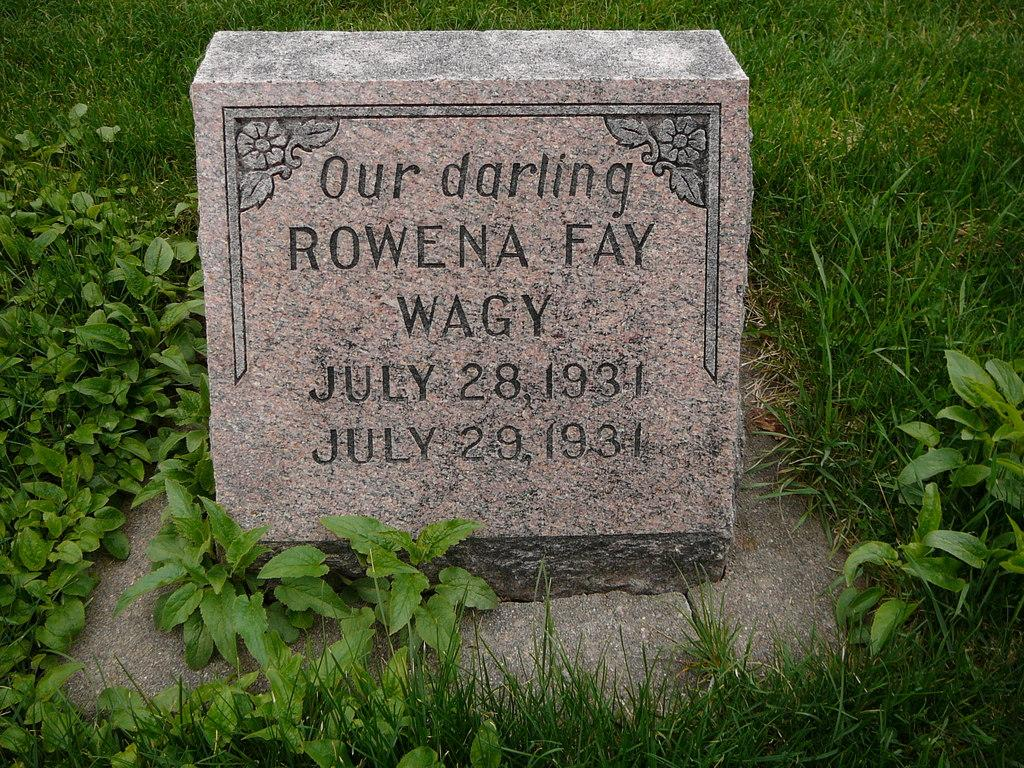What is the main subject in the image? There is a gravestone in the image. What type of vegetation is present around the gravestone? There are plants around the gravestone. What type of ground cover is visible around the gravestone? There is grass around the gravestone. What type of copper stem can be seen growing from the gravestone in the image? There is no copper stem present in the image; the image only features a gravestone, plants, and grass. 